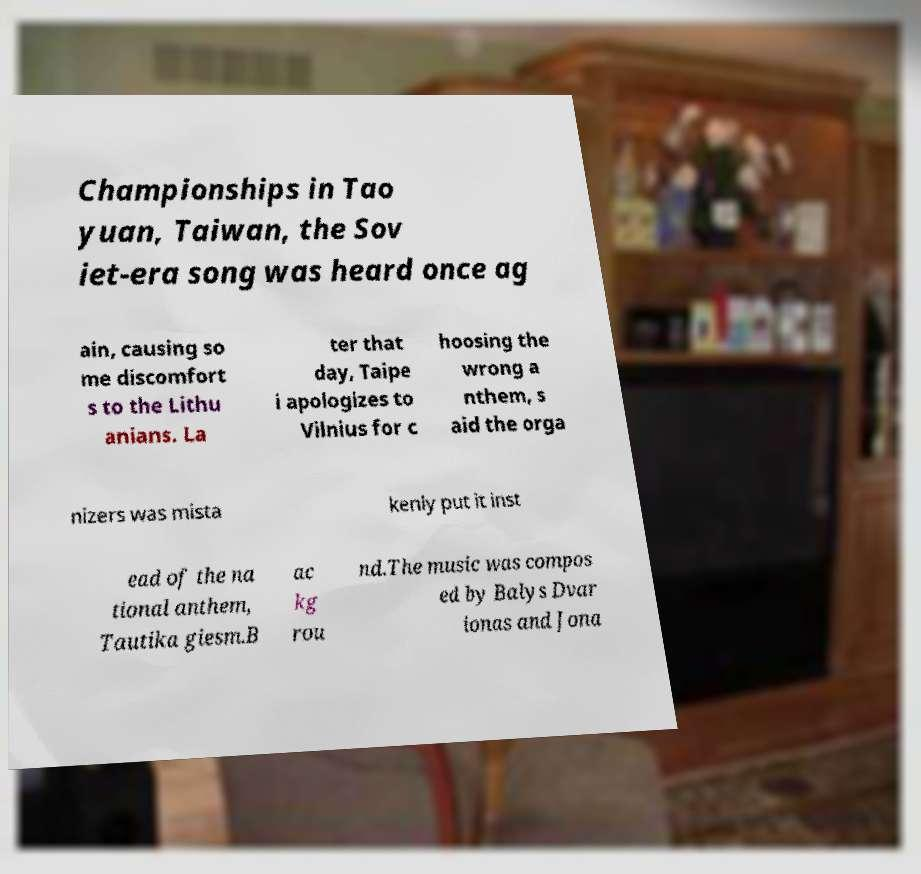Can you read and provide the text displayed in the image?This photo seems to have some interesting text. Can you extract and type it out for me? Championships in Tao yuan, Taiwan, the Sov iet-era song was heard once ag ain, causing so me discomfort s to the Lithu anians. La ter that day, Taipe i apologizes to Vilnius for c hoosing the wrong a nthem, s aid the orga nizers was mista kenly put it inst ead of the na tional anthem, Tautika giesm.B ac kg rou nd.The music was compos ed by Balys Dvar ionas and Jona 